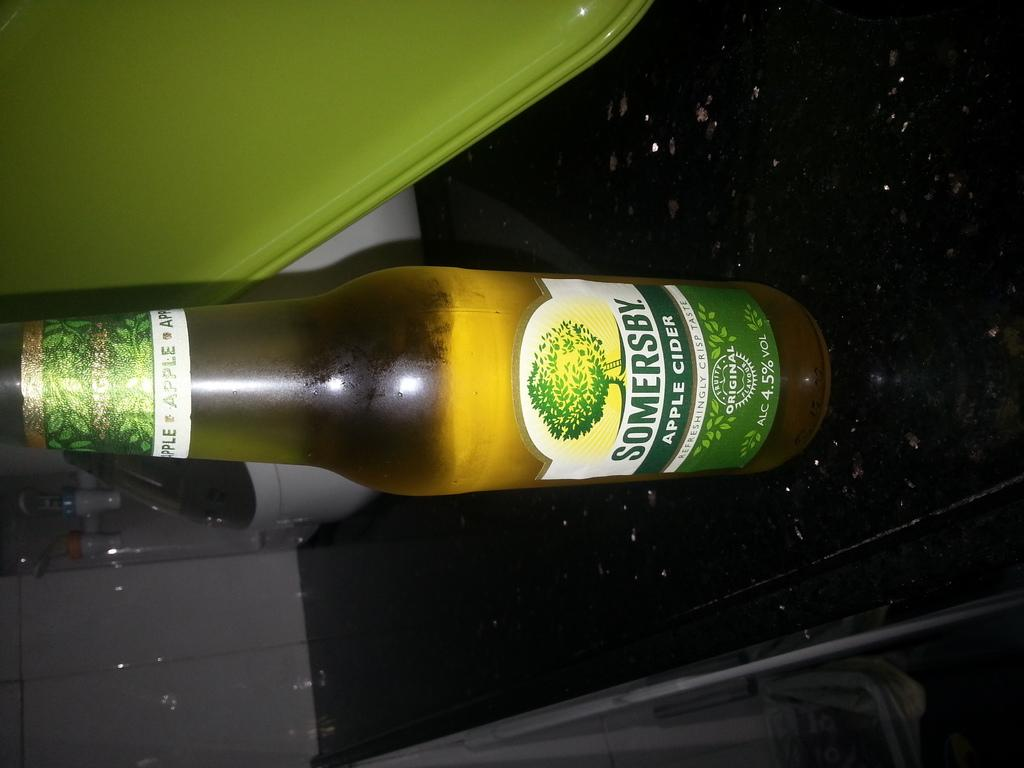<image>
Give a short and clear explanation of the subsequent image. A bottle of apple cider, made by Somersby, is on a table. 